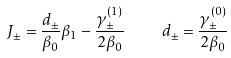Convert formula to latex. <formula><loc_0><loc_0><loc_500><loc_500>J _ { \pm } = \frac { d _ { \pm } } { \beta _ { 0 } } \beta _ { 1 } - \frac { \gamma ^ { ( 1 ) } _ { \pm } } { 2 \beta _ { 0 } } \quad d _ { \pm } = \frac { \gamma ^ { ( 0 ) } _ { \pm } } { 2 \beta _ { 0 } }</formula> 